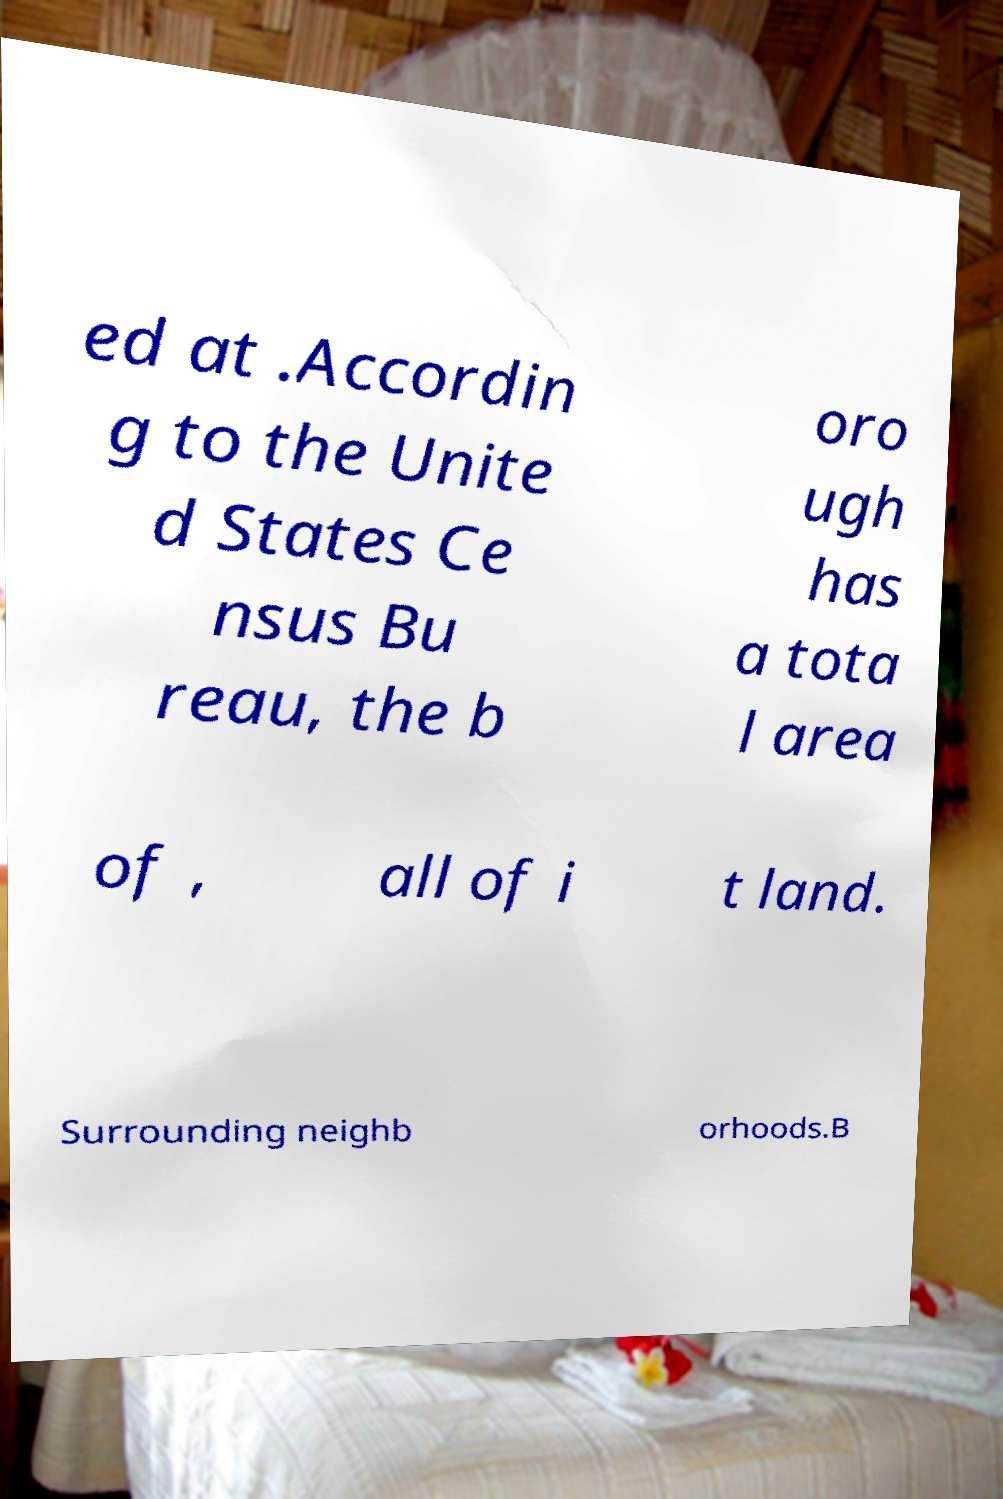What messages or text are displayed in this image? I need them in a readable, typed format. ed at .Accordin g to the Unite d States Ce nsus Bu reau, the b oro ugh has a tota l area of , all of i t land. Surrounding neighb orhoods.B 